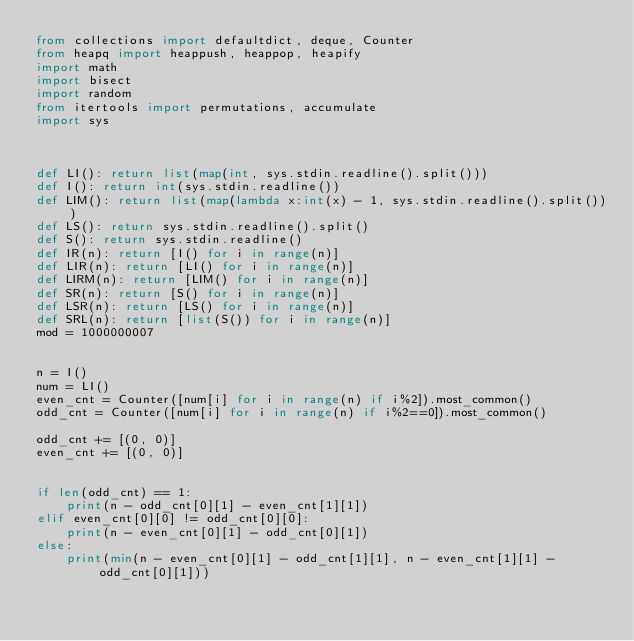<code> <loc_0><loc_0><loc_500><loc_500><_Python_>from collections import defaultdict, deque, Counter
from heapq import heappush, heappop, heapify
import math
import bisect
import random
from itertools import permutations, accumulate
import sys



def LI(): return list(map(int, sys.stdin.readline().split()))
def I(): return int(sys.stdin.readline())
def LIM(): return list(map(lambda x:int(x) - 1, sys.stdin.readline().split()))
def LS(): return sys.stdin.readline().split()
def S(): return sys.stdin.readline()
def IR(n): return [I() for i in range(n)]
def LIR(n): return [LI() for i in range(n)]
def LIRM(n): return [LIM() for i in range(n)]
def SR(n): return [S() for i in range(n)]
def LSR(n): return [LS() for i in range(n)]
def SRL(n): return [list(S()) for i in range(n)]
mod = 1000000007


n = I()
num = LI()
even_cnt = Counter([num[i] for i in range(n) if i%2]).most_common()
odd_cnt = Counter([num[i] for i in range(n) if i%2==0]).most_common()

odd_cnt += [(0, 0)]
even_cnt += [(0, 0)]


if len(odd_cnt) == 1:
    print(n - odd_cnt[0][1] - even_cnt[1][1])
elif even_cnt[0][0] != odd_cnt[0][0]:
    print(n - even_cnt[0][1] - odd_cnt[0][1])
else:
    print(min(n - even_cnt[0][1] - odd_cnt[1][1], n - even_cnt[1][1] - odd_cnt[0][1]))</code> 